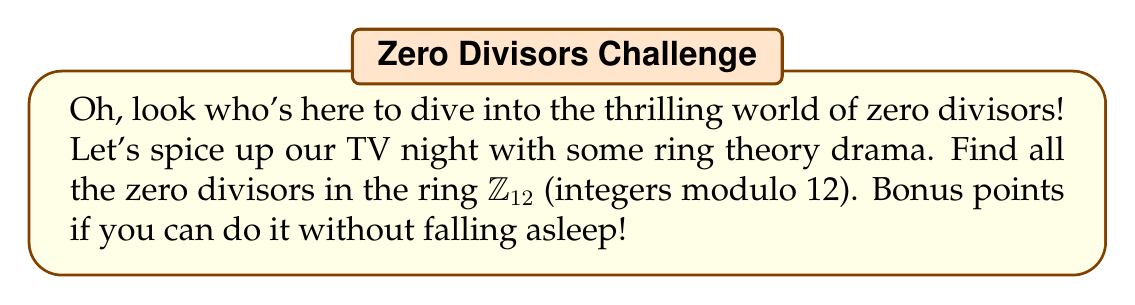Give your solution to this math problem. Alright, time to break this down for our math-challenged sibling:

1) First, let's remember what a zero divisor is. In a ring, a non-zero element $a$ is a zero divisor if there exists a non-zero element $b$ such that $ab = 0$ (or $ba = 0$).

2) In $\mathbb{Z}_{12}$, we're dealing with integers from 0 to 11. Let's go through each non-zero element:

   1: Not a zero divisor (it's always 1 times something)
   2: $2 \cdot 6 = 12 \equiv 0 \pmod{12}$, so 2 is a zero divisor
   3: $3 \cdot 4 = 12 \equiv 0 \pmod{12}$, so 3 is a zero divisor
   4: $4 \cdot 3 = 12 \equiv 0 \pmod{12}$, so 4 is a zero divisor
   5: Not a zero divisor
   6: $6 \cdot 2 = 12 \equiv 0 \pmod{12}$, so 6 is a zero divisor
   7: Not a zero divisor
   8: $8 \cdot 3 = 24 \equiv 0 \pmod{12}$, so 8 is a zero divisor
   9: $9 \cdot 4 = 36 \equiv 0 \pmod{12}$, so 9 is a zero divisor
   10: $10 \cdot 6 = 60 \equiv 0 \pmod{12}$, so 10 is a zero divisor
   11: Not a zero divisor

3) And there you have it! The zero divisors are 2, 3, 4, 6, 8, 9, and 10.

Now, wasn't that more exciting than whatever's on TV?
Answer: The zero divisors in $\mathbb{Z}_{12}$ are $\{2, 3, 4, 6, 8, 9, 10\}$. 